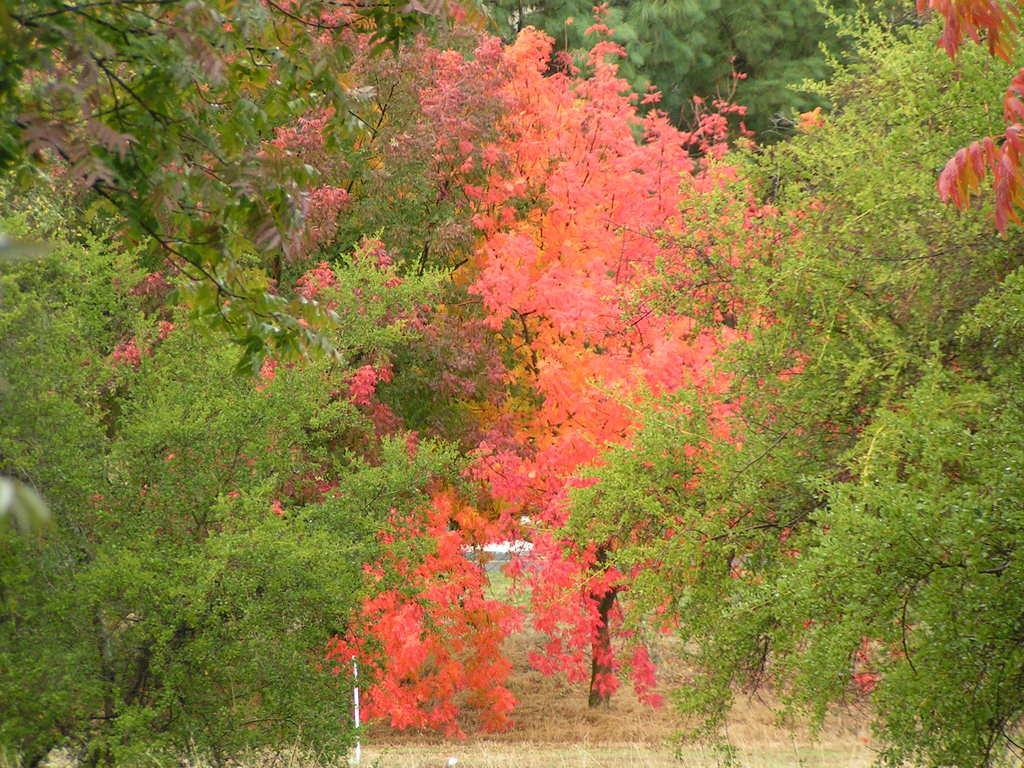What type of vegetation is present at the bottom of the image? There are trees at the bottom of the image. What is covering the ground at the bottom of the image? There is grass on the ground at the bottom of the image. What can be seen in the background of the image? There are trees in the background of the image. How many elbows can be seen in the image? There are no elbows present in the image. Are there any giants visible in the image? There are no giants present in the image. 